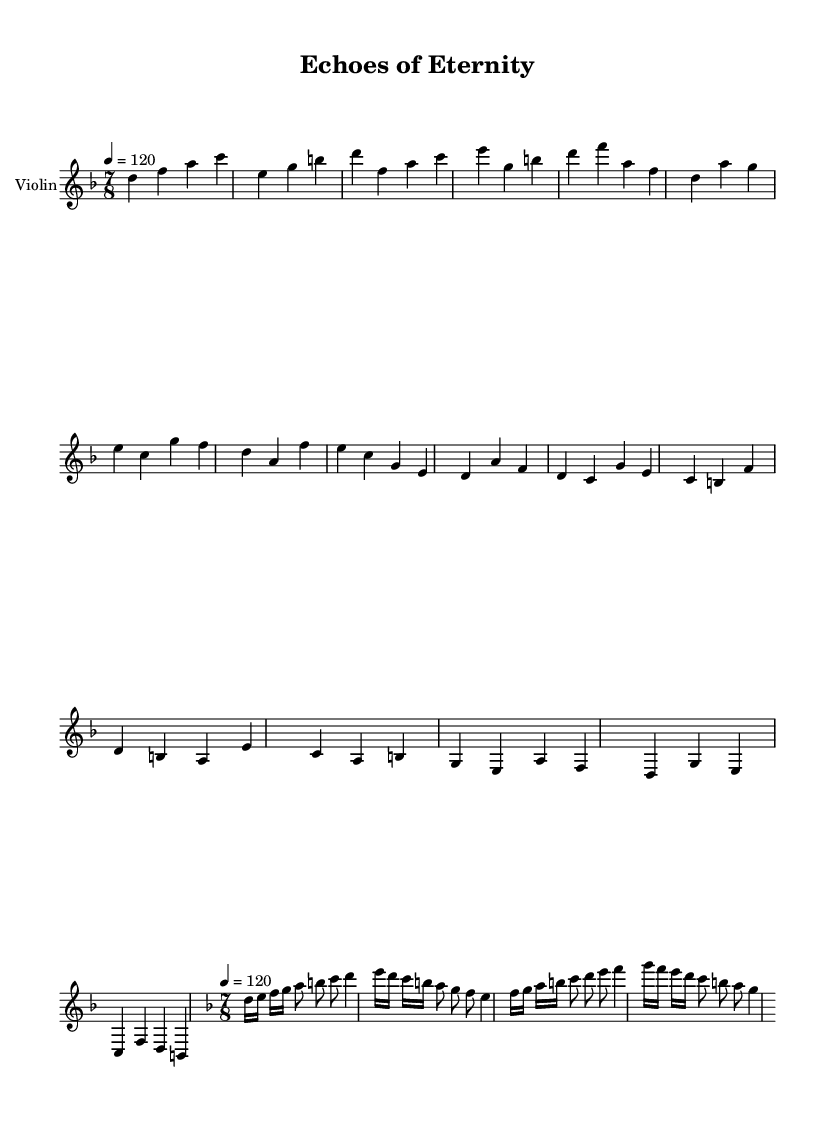What is the key signature of this music? The key signature shown in the music indicates D minor. It consists of one flat (B♭), which is characteristic of D minor.
Answer: D minor What is the time signature of this music? The time signature displayed in the music is 7/8. This is determined by the numeral indicating the top number (7) and the bottom number (8).
Answer: 7/8 What is the tempo marking for this piece? The tempo indicated in the score is 4 = 120. This means there are 120 beats per minute, and it suggests a moderate pace for the piece.
Answer: 120 How many measures are in the violin solo section? By counting the segment of the sheet music marked as violinSolo, we see that there are four measures total in this section.
Answer: 4 What is the highest note in the violin solo? The highest note reached in the violin solo is D4. Looking through the solo, D4 is the highest pitch that appears in that segment.
Answer: D4 What are the dynamics in the main violin part? The dynamics are not explicitly indicated in the provided code, which implies a consistent volume unless specified otherwise. This can point to a more rock-oriented approach where dynamics may vary but aren't explicitly notated.
Answer: Not specified How does the violin complement the progressive rock style? The violin incorporates classical violin techniques and solos, creating lush melodies and harmonies that are distinctive for progressive rock, which often blends rock with orchestral elements.
Answer: Classical elements 